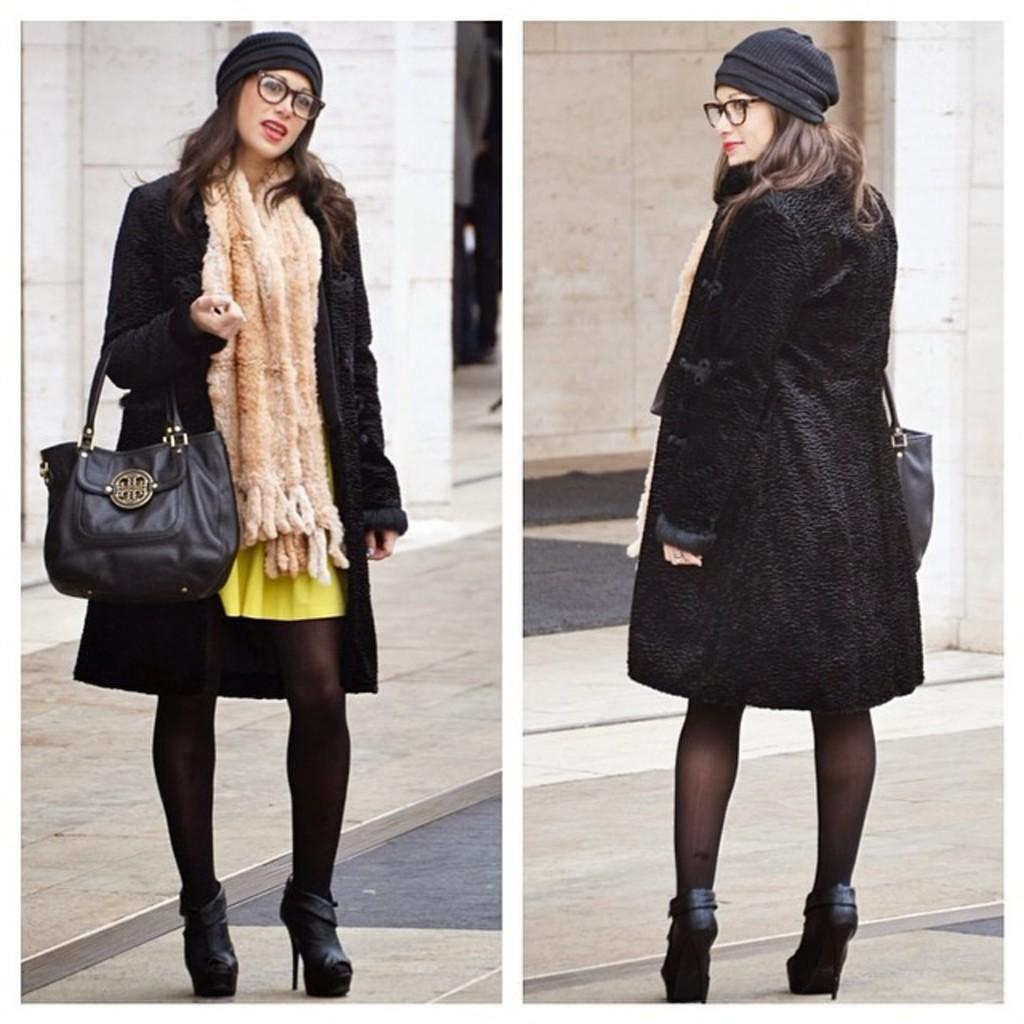Who is present in the image? There is a woman in the image. What is the woman holding in the image? The woman is holding a black color handbag. What type of destruction can be seen happening in the image? There is no destruction present in the image; it features a woman holding a black color handbag. Can you tell me how many mines are visible in the image? There are no mines present in the image. 